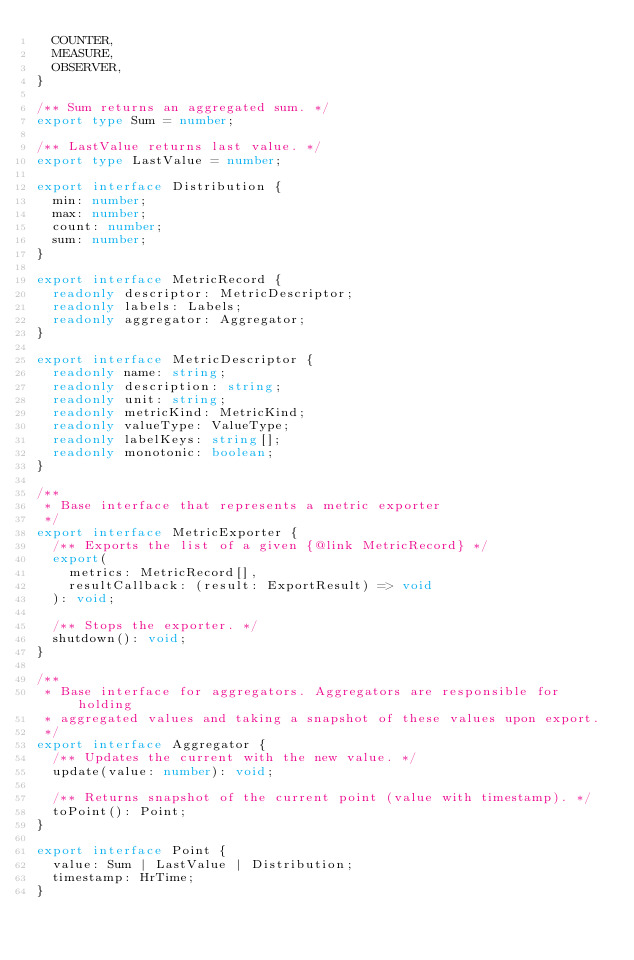<code> <loc_0><loc_0><loc_500><loc_500><_TypeScript_>  COUNTER,
  MEASURE,
  OBSERVER,
}

/** Sum returns an aggregated sum. */
export type Sum = number;

/** LastValue returns last value. */
export type LastValue = number;

export interface Distribution {
  min: number;
  max: number;
  count: number;
  sum: number;
}

export interface MetricRecord {
  readonly descriptor: MetricDescriptor;
  readonly labels: Labels;
  readonly aggregator: Aggregator;
}

export interface MetricDescriptor {
  readonly name: string;
  readonly description: string;
  readonly unit: string;
  readonly metricKind: MetricKind;
  readonly valueType: ValueType;
  readonly labelKeys: string[];
  readonly monotonic: boolean;
}

/**
 * Base interface that represents a metric exporter
 */
export interface MetricExporter {
  /** Exports the list of a given {@link MetricRecord} */
  export(
    metrics: MetricRecord[],
    resultCallback: (result: ExportResult) => void
  ): void;

  /** Stops the exporter. */
  shutdown(): void;
}

/**
 * Base interface for aggregators. Aggregators are responsible for holding
 * aggregated values and taking a snapshot of these values upon export.
 */
export interface Aggregator {
  /** Updates the current with the new value. */
  update(value: number): void;

  /** Returns snapshot of the current point (value with timestamp). */
  toPoint(): Point;
}

export interface Point {
  value: Sum | LastValue | Distribution;
  timestamp: HrTime;
}
</code> 